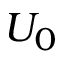Convert formula to latex. <formula><loc_0><loc_0><loc_500><loc_500>U _ { 0 }</formula> 